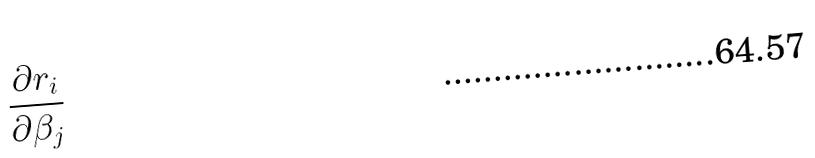<formula> <loc_0><loc_0><loc_500><loc_500>\frac { \partial r _ { i } } { \partial \beta _ { j } }</formula> 